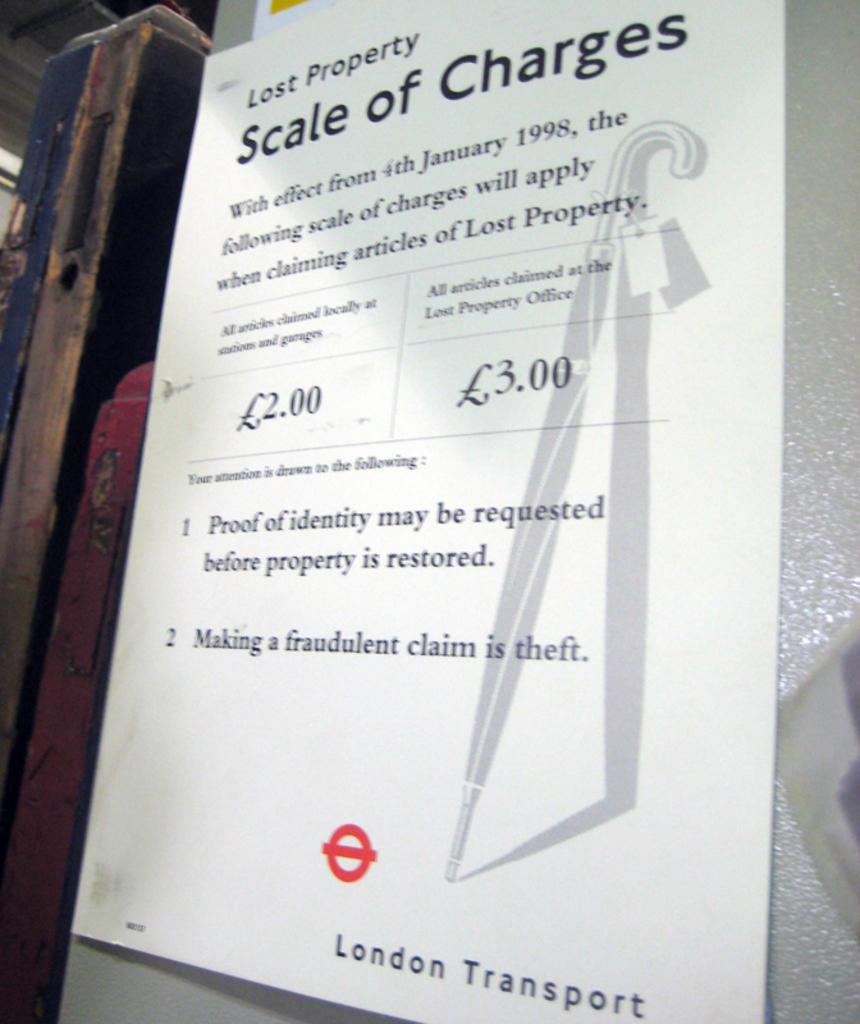<image>
Describe the image concisely. A london transport lost property scale of charges paper 